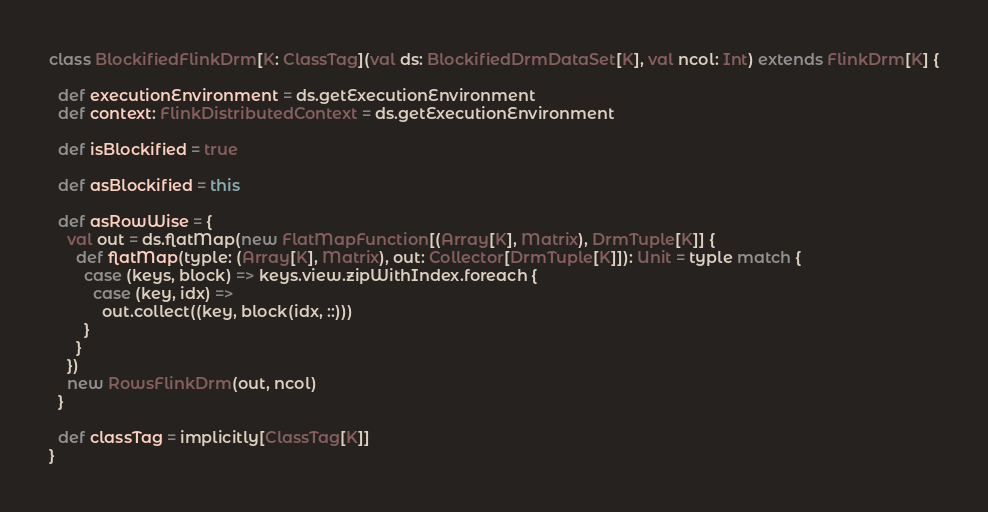<code> <loc_0><loc_0><loc_500><loc_500><_Scala_>
class BlockifiedFlinkDrm[K: ClassTag](val ds: BlockifiedDrmDataSet[K], val ncol: Int) extends FlinkDrm[K] {

  def executionEnvironment = ds.getExecutionEnvironment
  def context: FlinkDistributedContext = ds.getExecutionEnvironment

  def isBlockified = true

  def asBlockified = this

  def asRowWise = {
    val out = ds.flatMap(new FlatMapFunction[(Array[K], Matrix), DrmTuple[K]] {
      def flatMap(typle: (Array[K], Matrix), out: Collector[DrmTuple[K]]): Unit = typle match {
        case (keys, block) => keys.view.zipWithIndex.foreach {
          case (key, idx) =>
            out.collect((key, block(idx, ::)))
        }
      }
    })
    new RowsFlinkDrm(out, ncol)
  }

  def classTag = implicitly[ClassTag[K]]
}</code> 